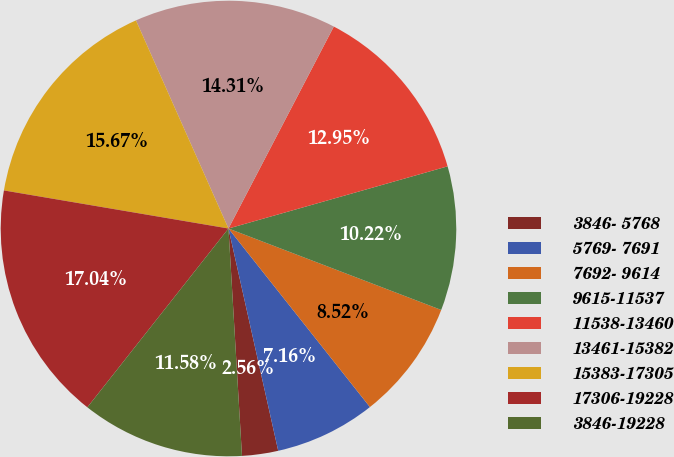<chart> <loc_0><loc_0><loc_500><loc_500><pie_chart><fcel>3846- 5768<fcel>5769- 7691<fcel>7692- 9614<fcel>9615-11537<fcel>11538-13460<fcel>13461-15382<fcel>15383-17305<fcel>17306-19228<fcel>3846-19228<nl><fcel>2.56%<fcel>7.16%<fcel>8.52%<fcel>10.22%<fcel>12.95%<fcel>14.31%<fcel>15.67%<fcel>17.04%<fcel>11.58%<nl></chart> 